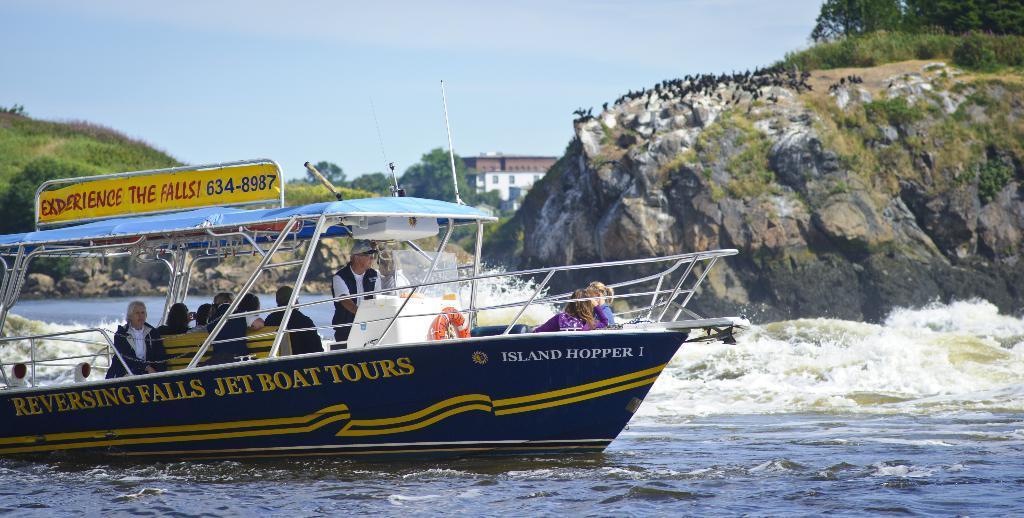In one or two sentences, can you explain what this image depicts? In this picture there is a boat on the river towards the left bottom. The boat is in blue in color with some text. In the boat there is a man sailing the boat. Behind the man, there is a bench. On the bench there are group of people sitting on it. In the background there are hills, buildings and sky. 